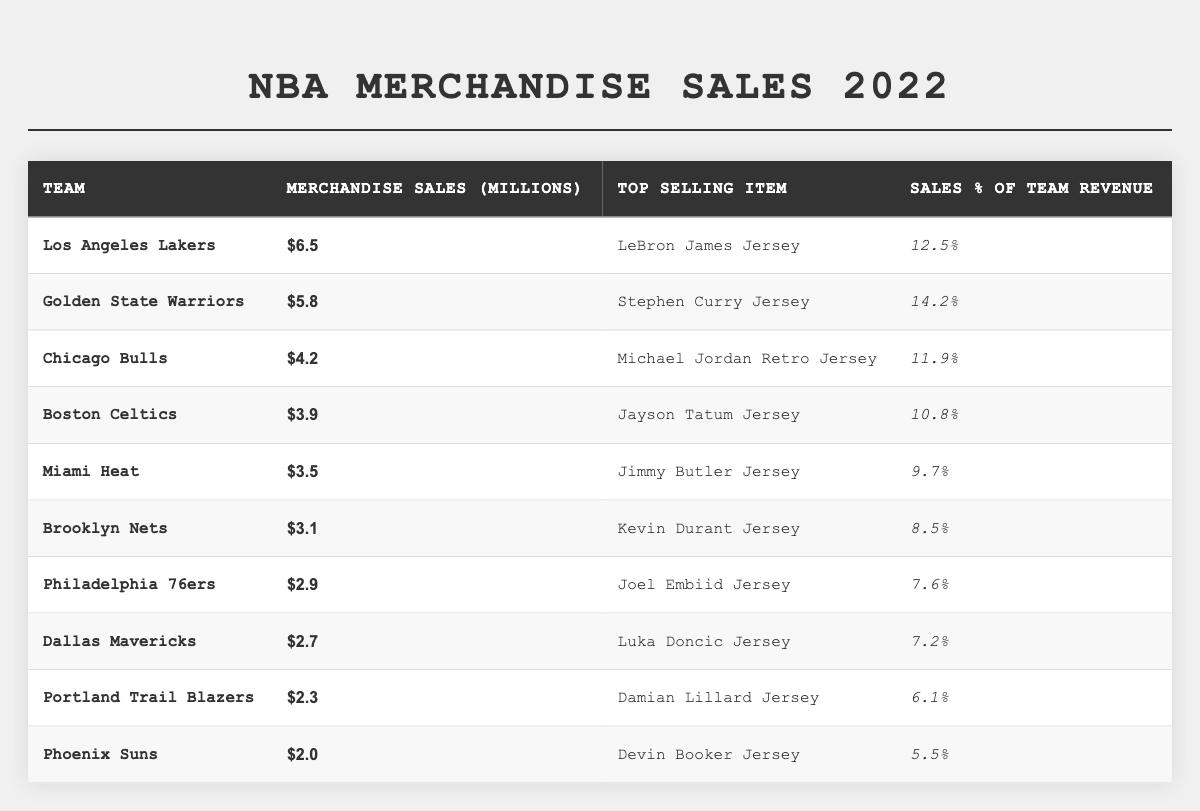What team had the highest merchandise sales in 2022? By reviewing the table, we see that the Los Angeles Lakers have merchandise sales of $6.5 million, which is higher than any other team listed.
Answer: Los Angeles Lakers What was the top-selling item for the Golden State Warriors? The table lists the top-selling item for the Golden State Warriors as the Stephen Curry Jersey.
Answer: Stephen Curry Jersey What is the total merchandise sales for the top three teams? The total sales for the top three teams (Los Angeles Lakers: $6.5M, Golden State Warriors: $5.8M, and Chicago Bulls: $4.2M) can be calculated as $6.5M + $5.8M + $4.2M = $16.5M.
Answer: $16.5 million Which team had the lowest merchandise sales, and what was the amount? The lowest merchandise sales in the table are listed for the Phoenix Suns at $2.0 million.
Answer: Phoenix Suns, $2.0 million What percentage of team revenue does merchandise sales represent for the Dallas Mavericks? According to the table, the Dallas Mavericks have merchandise sales representing 7.2% of their team revenue.
Answer: 7.2% Which team had a higher merchandise sales percentage of team revenue: Miami Heat or Brooklyn Nets? Miami Heat has 9.7% and Brooklyn Nets has 8.5%. Since 9.7% is greater than 8.5%, Miami Heat has a higher percentage.
Answer: Miami Heat What is the average merchandise sales among all the teams listed? To calculate the average, we first sum all merchandise sales: $6.5 + $5.8 + $4.2 + $3.9 + $3.5 + $3.1 + $2.9 + $2.7 + $2.3 + $2.0 = $34.0 million. There are 10 teams, so the average is $34.0 million / 10 = $3.4 million.
Answer: $3.4 million Did any of the teams generate merchandise sales above $4 million? From the table, three teams (Los Angeles Lakers, Golden State Warriors, and Chicago Bulls) have sales above $4 million, confirming the statement is true.
Answer: Yes How much more did the Los Angeles Lakers earn in merchandise sales compared to the Phoenix Suns? The difference between Lakers sales ($6.5 million) and Suns sales ($2.0 million) can be calculated as $6.5 million - $2.0 million = $4.5 million.
Answer: $4.5 million Which team's merchandise sales contributed the most to their revenue as a percentage? The Golden State Warriors with 14.2% had the highest percentage contribution to their revenue from merchandise sales as indicated in the table.
Answer: Golden State Warriors 